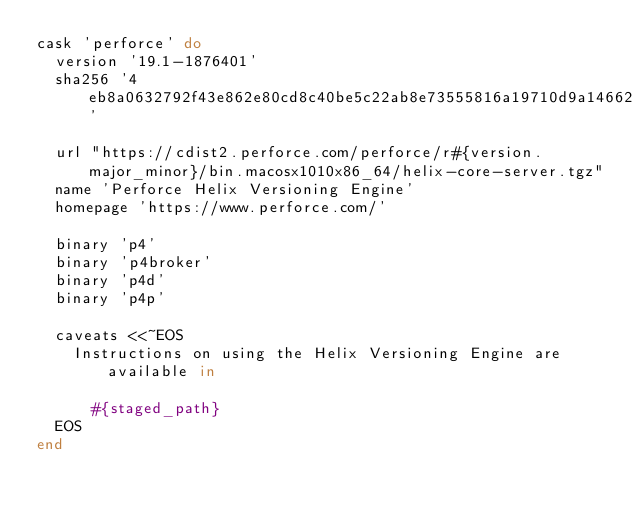Convert code to text. <code><loc_0><loc_0><loc_500><loc_500><_Ruby_>cask 'perforce' do
  version '19.1-1876401'
  sha256 '4eb8a0632792f43e862e80cd8c40be5c22ab8e73555816a19710d9a1466298af'

  url "https://cdist2.perforce.com/perforce/r#{version.major_minor}/bin.macosx1010x86_64/helix-core-server.tgz"
  name 'Perforce Helix Versioning Engine'
  homepage 'https://www.perforce.com/'

  binary 'p4'
  binary 'p4broker'
  binary 'p4d'
  binary 'p4p'

  caveats <<~EOS
    Instructions on using the Helix Versioning Engine are available in

      #{staged_path}
  EOS
end
</code> 